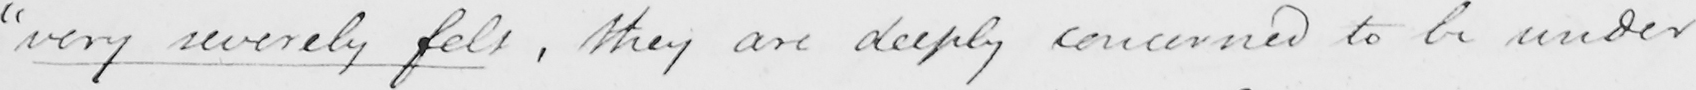Please transcribe the handwritten text in this image. " very severely felt  , they are deeply concerned to be under 